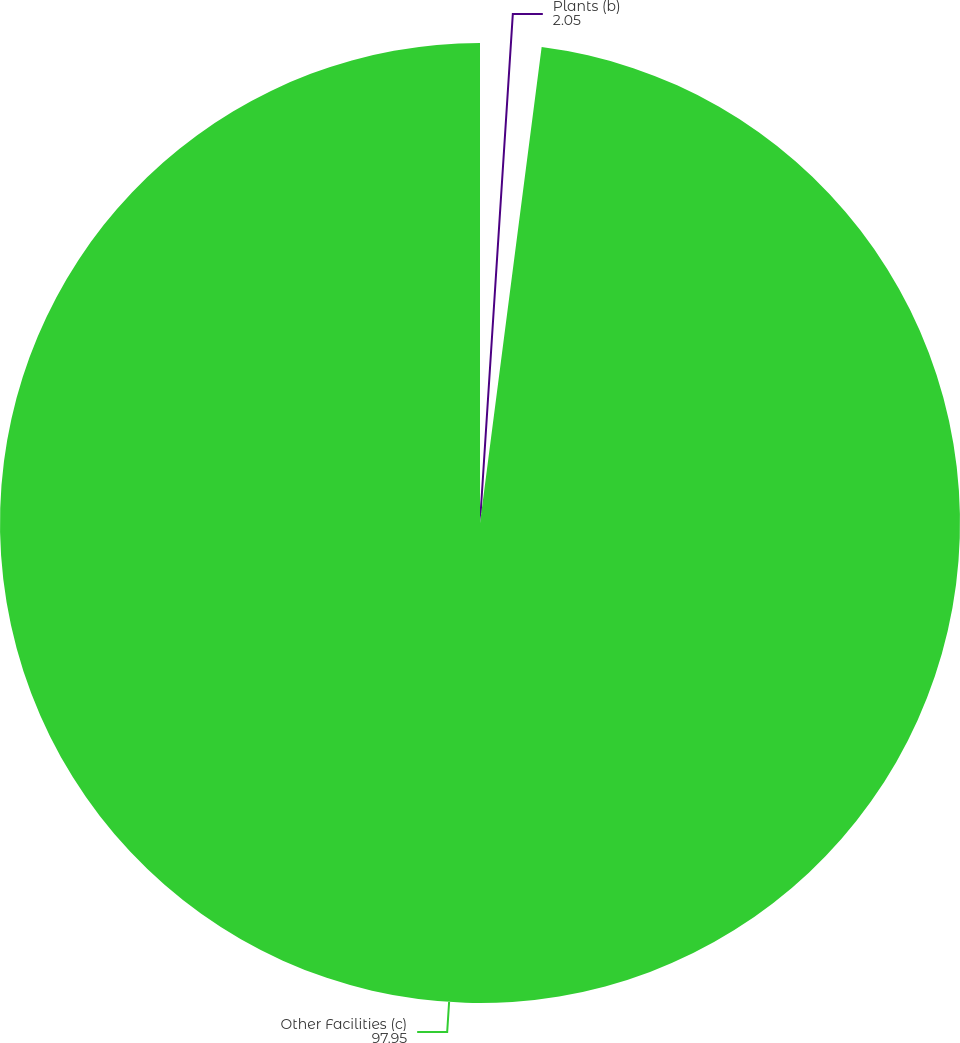<chart> <loc_0><loc_0><loc_500><loc_500><pie_chart><fcel>Plants (b)<fcel>Other Facilities (c)<nl><fcel>2.05%<fcel>97.95%<nl></chart> 